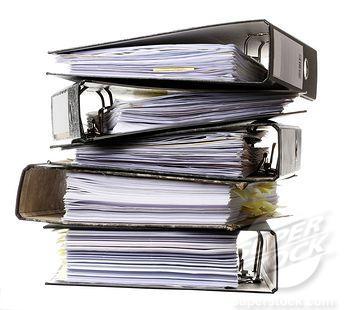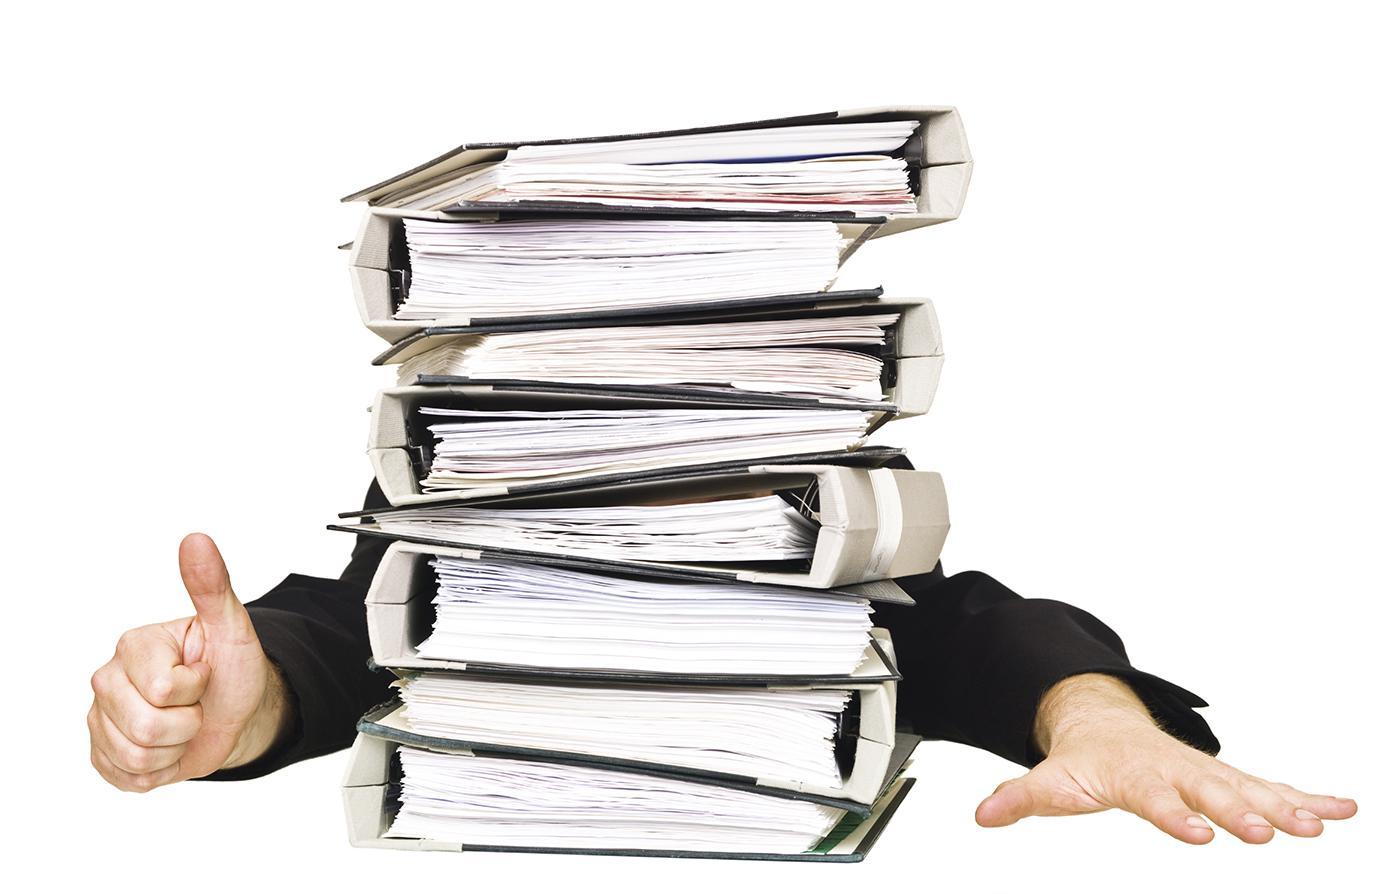The first image is the image on the left, the second image is the image on the right. Analyze the images presented: Is the assertion "The right image contains a stack of binders with a person sitting behind it." valid? Answer yes or no. Yes. The first image is the image on the left, the second image is the image on the right. Evaluate the accuracy of this statement regarding the images: "There is a person behind a stack of binders.". Is it true? Answer yes or no. Yes. 